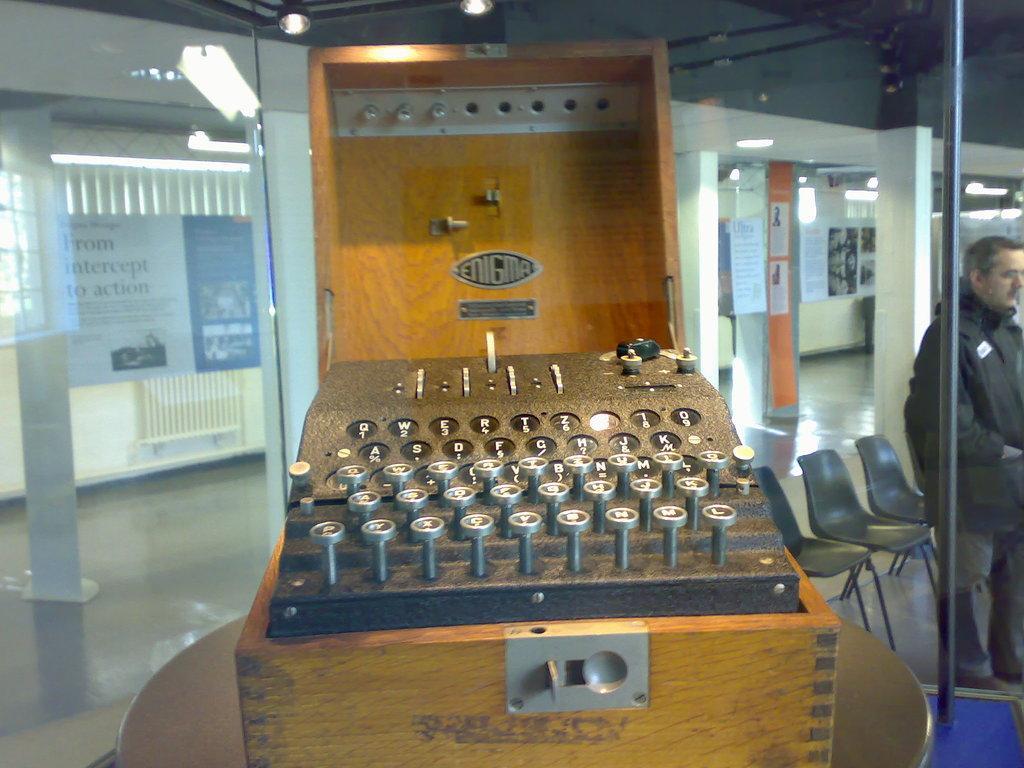Describe this image in one or two sentences. This image is taken indoors. At the bottom of the image there is a table with a typewriter on it. On the right side of the image a man is standing on the floor and there are a few empty chairs. In the background there is a wall, pillars, posters, banners and lamps. At the top of the image there is a roof. 